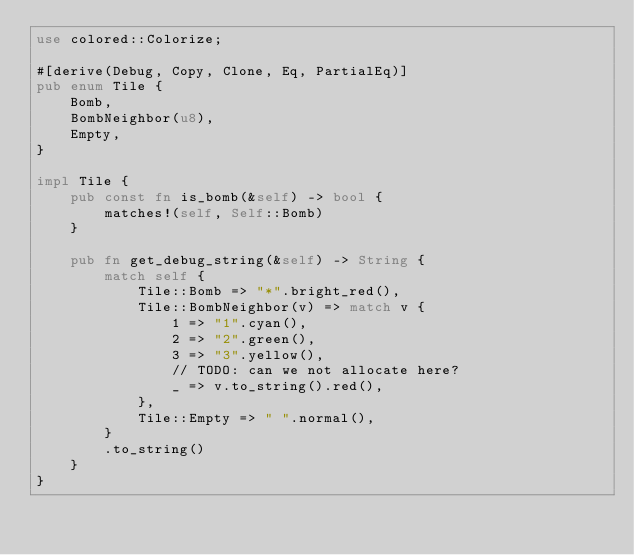<code> <loc_0><loc_0><loc_500><loc_500><_Rust_>use colored::Colorize;

#[derive(Debug, Copy, Clone, Eq, PartialEq)]
pub enum Tile {
    Bomb,
    BombNeighbor(u8),
    Empty,
}

impl Tile {
    pub const fn is_bomb(&self) -> bool {
        matches!(self, Self::Bomb)
    }

    pub fn get_debug_string(&self) -> String {
        match self {
            Tile::Bomb => "*".bright_red(),
            Tile::BombNeighbor(v) => match v {
                1 => "1".cyan(),
                2 => "2".green(),
                3 => "3".yellow(),
                // TODO: can we not allocate here?
                _ => v.to_string().red(),
            },
            Tile::Empty => " ".normal(),
        }
        .to_string()
    }
}
</code> 